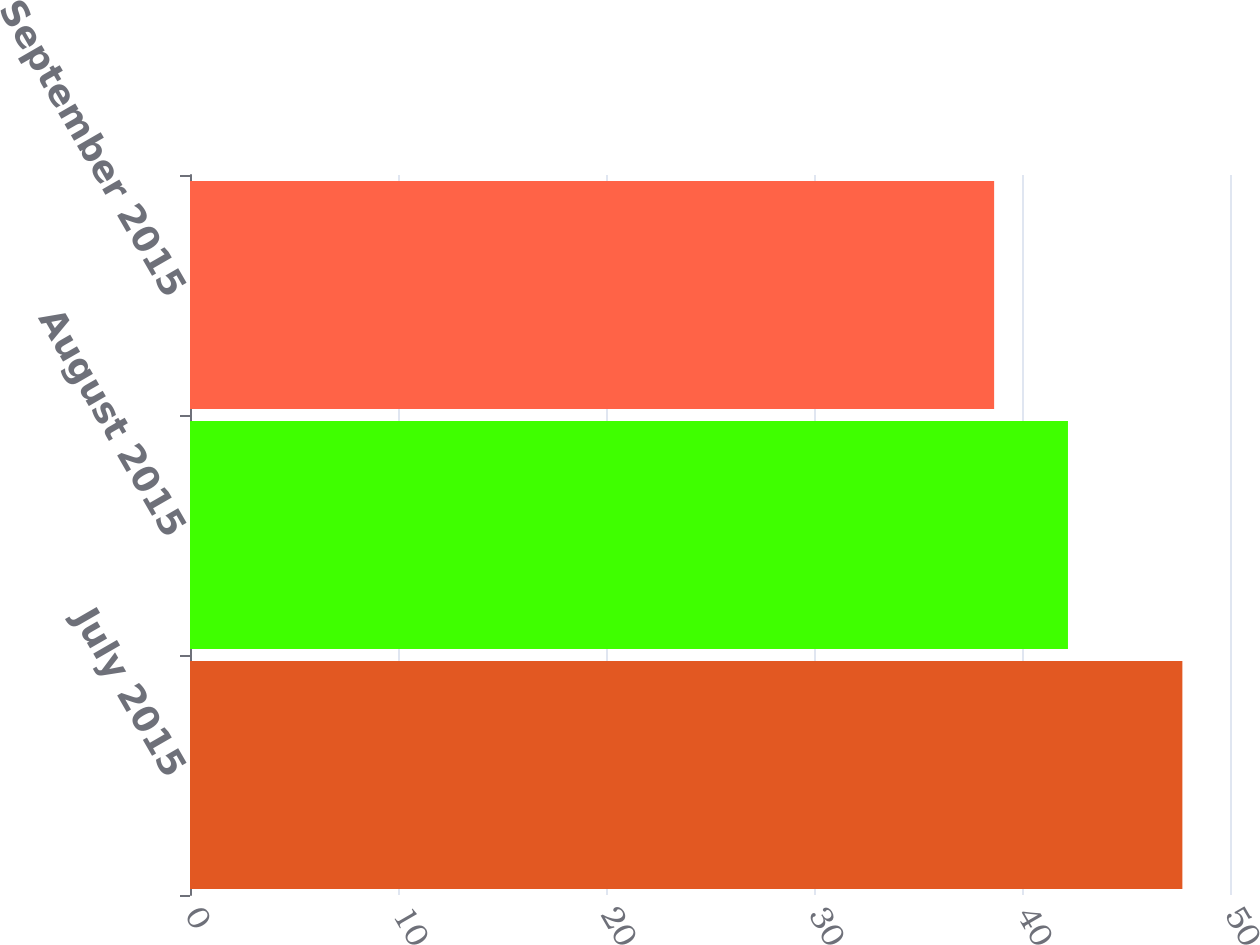Convert chart to OTSL. <chart><loc_0><loc_0><loc_500><loc_500><bar_chart><fcel>July 2015<fcel>August 2015<fcel>September 2015<nl><fcel>47.71<fcel>42.21<fcel>38.66<nl></chart> 